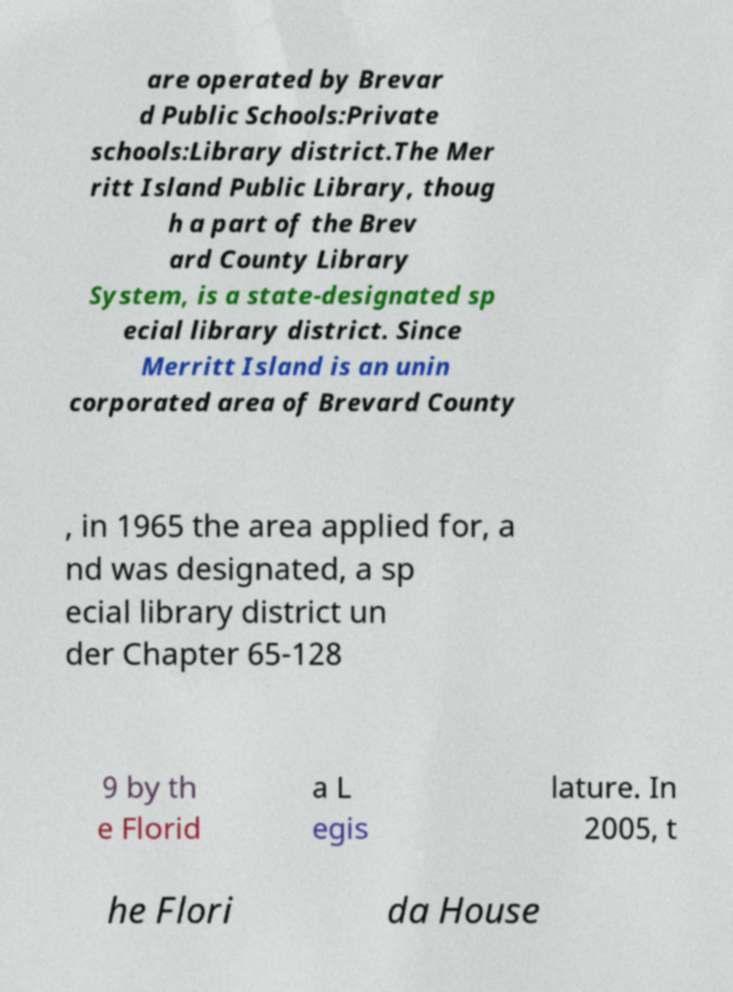What messages or text are displayed in this image? I need them in a readable, typed format. are operated by Brevar d Public Schools:Private schools:Library district.The Mer ritt Island Public Library, thoug h a part of the Brev ard County Library System, is a state-designated sp ecial library district. Since Merritt Island is an unin corporated area of Brevard County , in 1965 the area applied for, a nd was designated, a sp ecial library district un der Chapter 65-128 9 by th e Florid a L egis lature. In 2005, t he Flori da House 